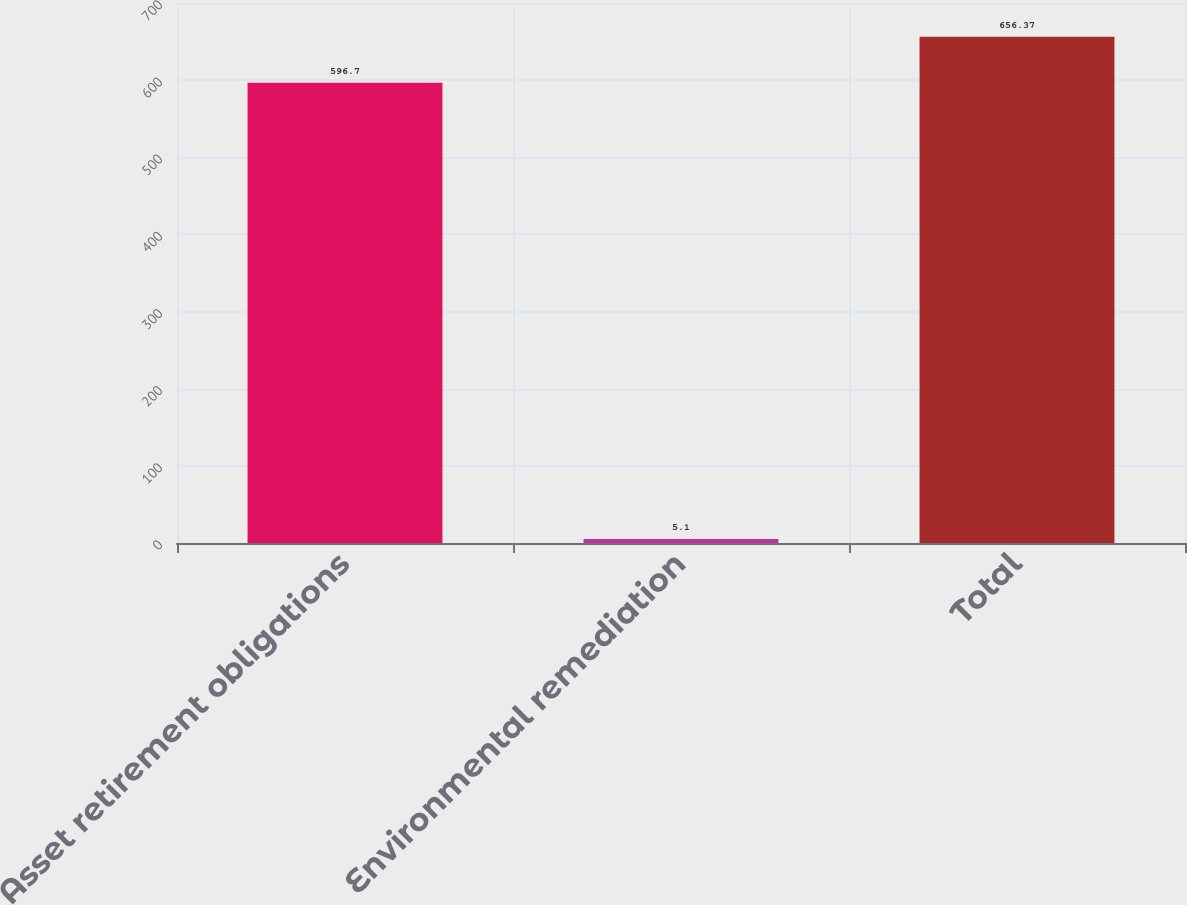Convert chart to OTSL. <chart><loc_0><loc_0><loc_500><loc_500><bar_chart><fcel>Asset retirement obligations<fcel>Environmental remediation<fcel>Total<nl><fcel>596.7<fcel>5.1<fcel>656.37<nl></chart> 